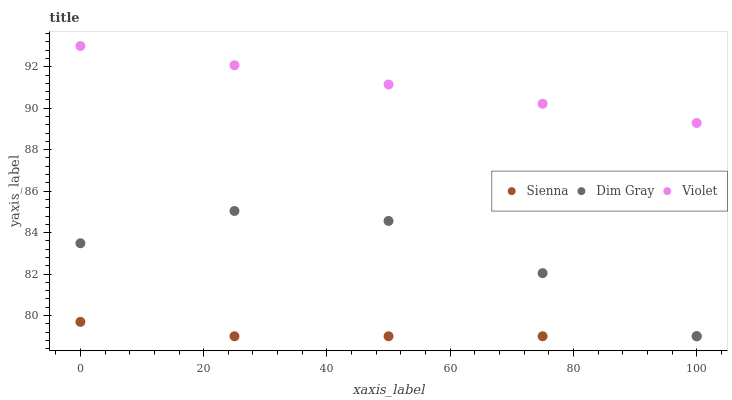Does Sienna have the minimum area under the curve?
Answer yes or no. Yes. Does Violet have the maximum area under the curve?
Answer yes or no. Yes. Does Dim Gray have the minimum area under the curve?
Answer yes or no. No. Does Dim Gray have the maximum area under the curve?
Answer yes or no. No. Is Violet the smoothest?
Answer yes or no. Yes. Is Dim Gray the roughest?
Answer yes or no. Yes. Is Dim Gray the smoothest?
Answer yes or no. No. Is Violet the roughest?
Answer yes or no. No. Does Sienna have the lowest value?
Answer yes or no. Yes. Does Violet have the lowest value?
Answer yes or no. No. Does Violet have the highest value?
Answer yes or no. Yes. Does Dim Gray have the highest value?
Answer yes or no. No. Is Sienna less than Violet?
Answer yes or no. Yes. Is Violet greater than Sienna?
Answer yes or no. Yes. Does Dim Gray intersect Sienna?
Answer yes or no. Yes. Is Dim Gray less than Sienna?
Answer yes or no. No. Is Dim Gray greater than Sienna?
Answer yes or no. No. Does Sienna intersect Violet?
Answer yes or no. No. 